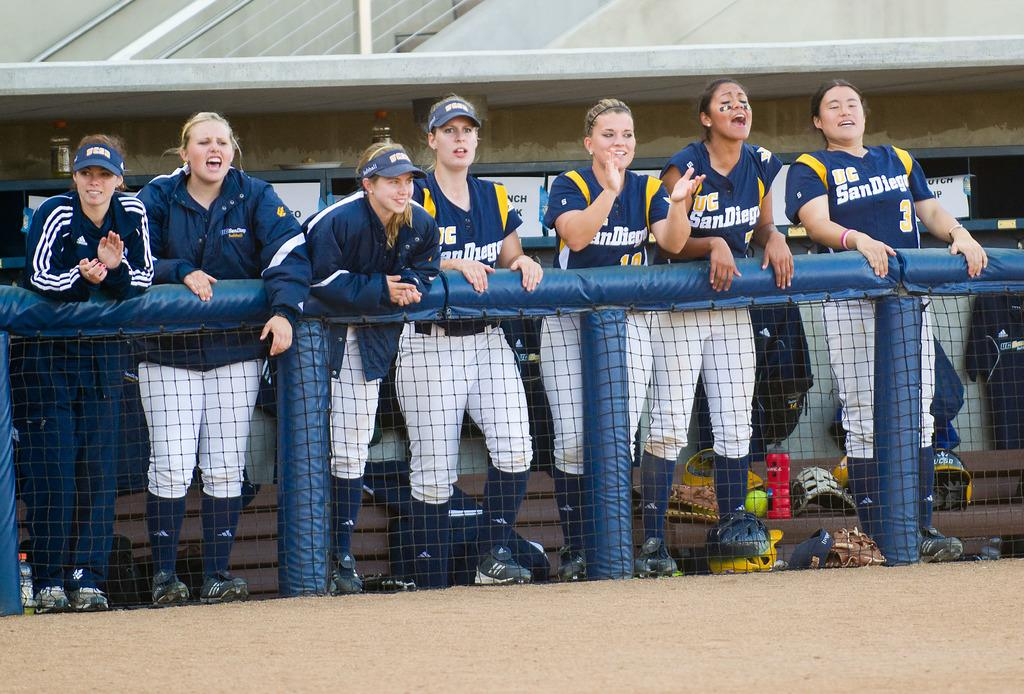<image>
Describe the image concisely. Several female softball players from UC San Diego are cheering from the dugout. 